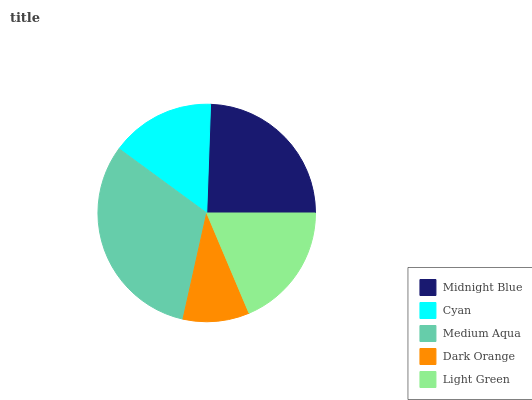Is Dark Orange the minimum?
Answer yes or no. Yes. Is Medium Aqua the maximum?
Answer yes or no. Yes. Is Cyan the minimum?
Answer yes or no. No. Is Cyan the maximum?
Answer yes or no. No. Is Midnight Blue greater than Cyan?
Answer yes or no. Yes. Is Cyan less than Midnight Blue?
Answer yes or no. Yes. Is Cyan greater than Midnight Blue?
Answer yes or no. No. Is Midnight Blue less than Cyan?
Answer yes or no. No. Is Light Green the high median?
Answer yes or no. Yes. Is Light Green the low median?
Answer yes or no. Yes. Is Midnight Blue the high median?
Answer yes or no. No. Is Cyan the low median?
Answer yes or no. No. 